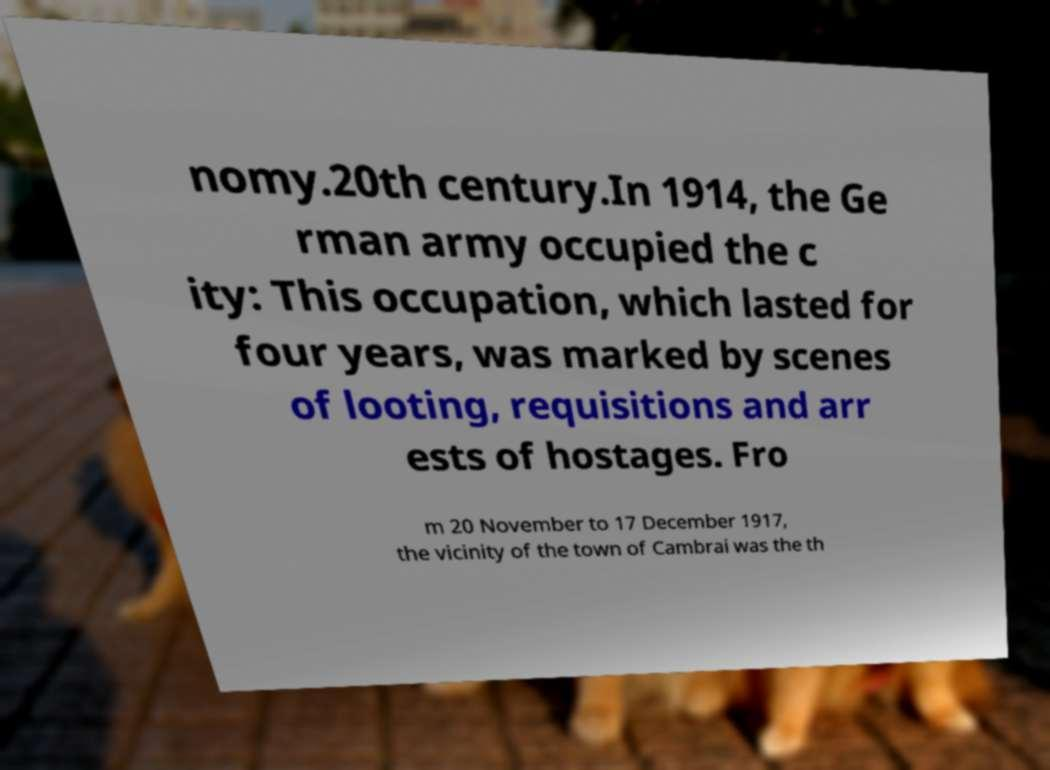Can you read and provide the text displayed in the image?This photo seems to have some interesting text. Can you extract and type it out for me? nomy.20th century.In 1914, the Ge rman army occupied the c ity: This occupation, which lasted for four years, was marked by scenes of looting, requisitions and arr ests of hostages. Fro m 20 November to 17 December 1917, the vicinity of the town of Cambrai was the th 